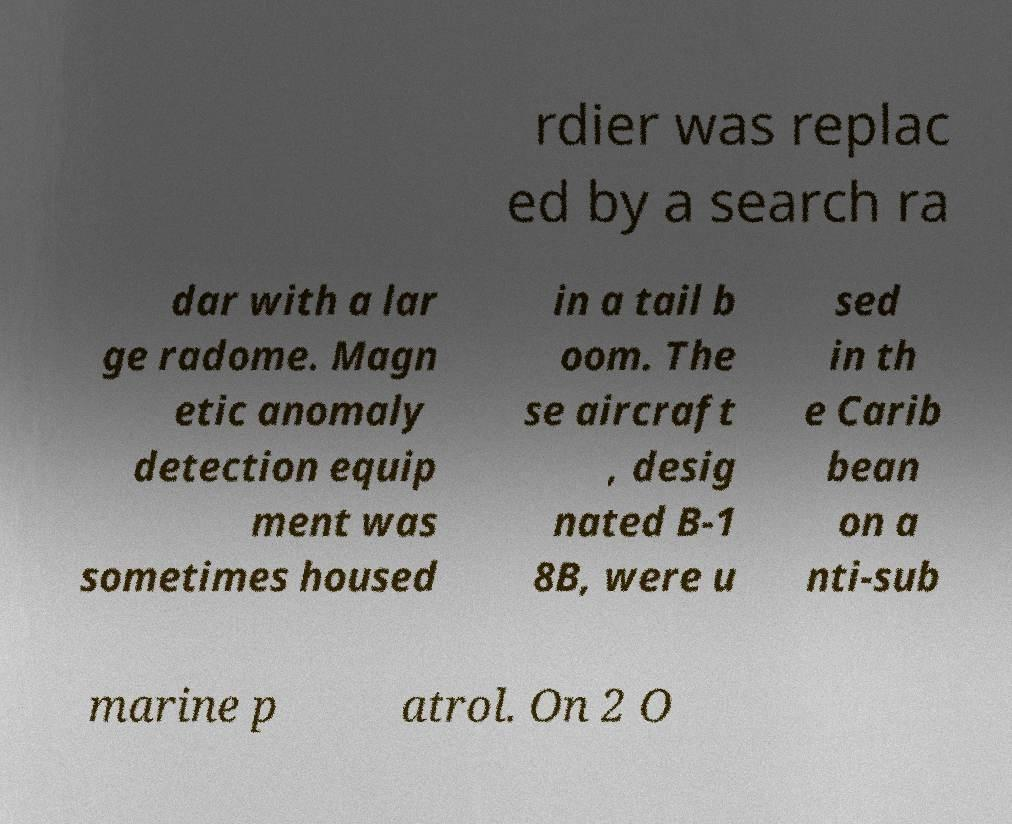Could you assist in decoding the text presented in this image and type it out clearly? rdier was replac ed by a search ra dar with a lar ge radome. Magn etic anomaly detection equip ment was sometimes housed in a tail b oom. The se aircraft , desig nated B-1 8B, were u sed in th e Carib bean on a nti-sub marine p atrol. On 2 O 